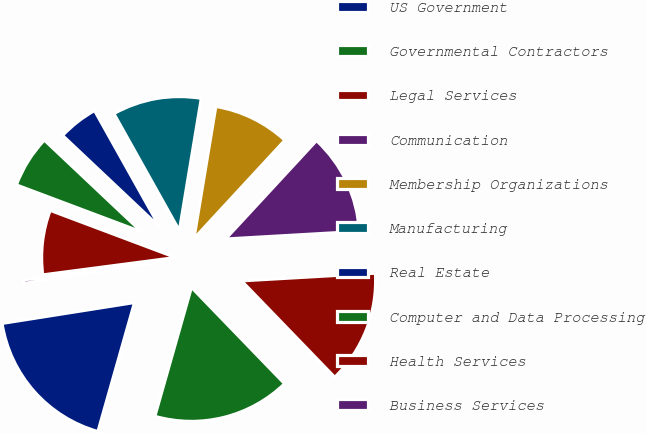<chart> <loc_0><loc_0><loc_500><loc_500><pie_chart><fcel>US Government<fcel>Governmental Contractors<fcel>Legal Services<fcel>Communication<fcel>Membership Organizations<fcel>Manufacturing<fcel>Real Estate<fcel>Computer and Data Processing<fcel>Health Services<fcel>Business Services<nl><fcel>18.11%<fcel>16.63%<fcel>13.68%<fcel>12.21%<fcel>9.26%<fcel>10.74%<fcel>4.84%<fcel>6.32%<fcel>7.79%<fcel>0.42%<nl></chart> 